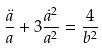<formula> <loc_0><loc_0><loc_500><loc_500>\frac { \ddot { a } } { a } + 3 \frac { \dot { a } ^ { 2 } } { a ^ { 2 } } = \frac { 4 } { b ^ { 2 } }</formula> 